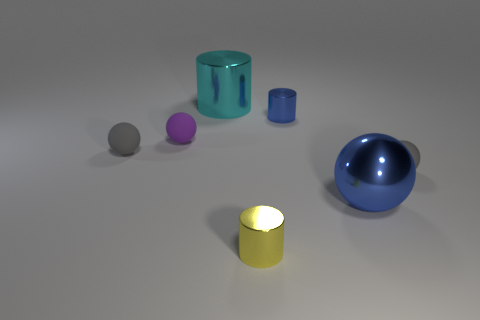What is the shape of the thing that is the same color as the large metal sphere?
Offer a very short reply. Cylinder. Is there a metal object that has the same color as the big metal sphere?
Give a very brief answer. Yes. There is a metal cylinder that is the same color as the big metallic ball; what is its size?
Your answer should be compact. Small. What number of other objects are there of the same shape as the tiny blue metallic thing?
Offer a terse response. 2. What is the size of the cyan thing?
Give a very brief answer. Large. What number of things are either blue metal spheres or yellow shiny cylinders?
Provide a short and direct response. 2. What size is the gray ball that is to the right of the blue cylinder?
Your answer should be compact. Small. There is a rubber object that is in front of the small purple rubber sphere and left of the yellow shiny cylinder; what is its color?
Provide a short and direct response. Gray. Is the material of the large thing to the left of the big blue ball the same as the tiny yellow cylinder?
Keep it short and to the point. Yes. There is a big shiny ball; does it have the same color as the tiny shiny cylinder that is behind the tiny purple rubber object?
Your response must be concise. Yes. 